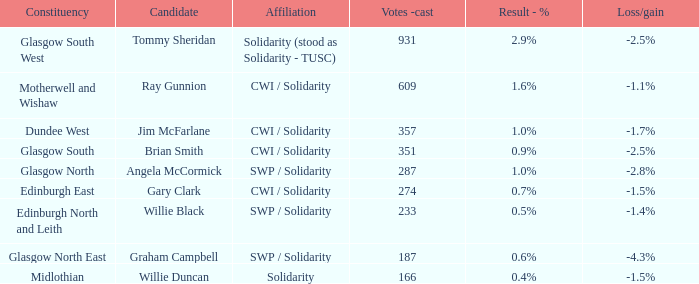4%? Willie Duncan. 